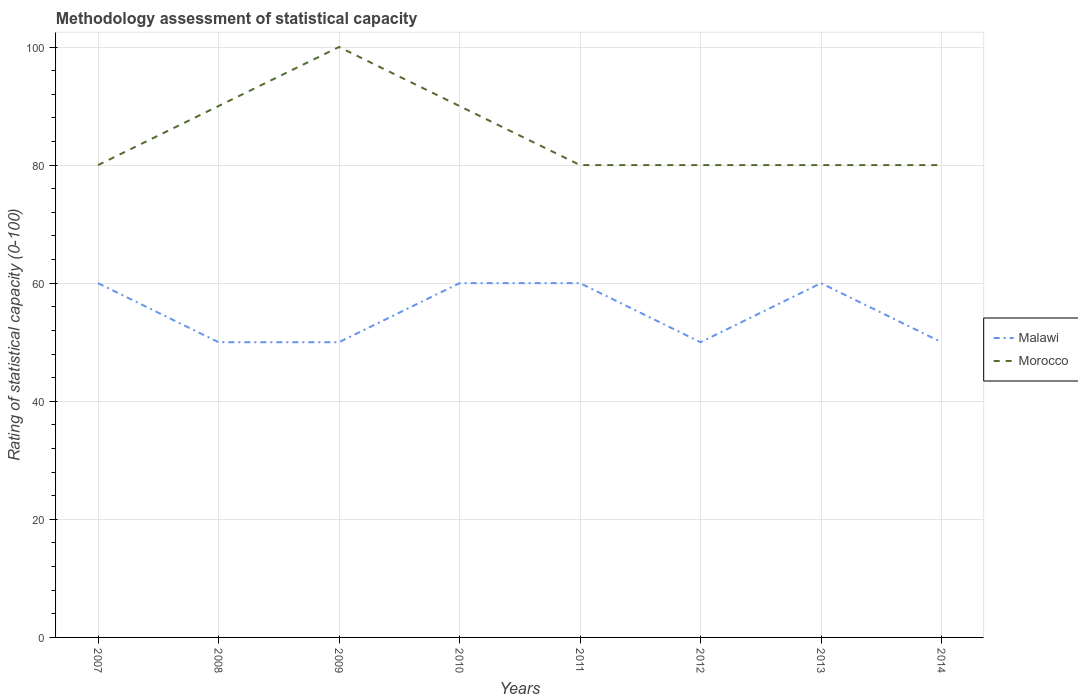How many different coloured lines are there?
Offer a terse response. 2. Is the number of lines equal to the number of legend labels?
Keep it short and to the point. Yes. Across all years, what is the maximum rating of statistical capacity in Morocco?
Offer a very short reply. 80. What is the total rating of statistical capacity in Morocco in the graph?
Offer a terse response. -10. What is the difference between the highest and the second highest rating of statistical capacity in Malawi?
Your answer should be compact. 10. Are the values on the major ticks of Y-axis written in scientific E-notation?
Your answer should be compact. No. Does the graph contain grids?
Your answer should be very brief. Yes. Where does the legend appear in the graph?
Make the answer very short. Center right. How are the legend labels stacked?
Offer a terse response. Vertical. What is the title of the graph?
Offer a very short reply. Methodology assessment of statistical capacity. What is the label or title of the X-axis?
Your answer should be very brief. Years. What is the label or title of the Y-axis?
Your answer should be very brief. Rating of statistical capacity (0-100). What is the Rating of statistical capacity (0-100) of Malawi in 2007?
Your response must be concise. 60. What is the Rating of statistical capacity (0-100) in Morocco in 2007?
Keep it short and to the point. 80. What is the Rating of statistical capacity (0-100) of Morocco in 2008?
Your answer should be very brief. 90. What is the Rating of statistical capacity (0-100) of Malawi in 2010?
Keep it short and to the point. 60. What is the Rating of statistical capacity (0-100) of Morocco in 2010?
Keep it short and to the point. 90. What is the Rating of statistical capacity (0-100) in Malawi in 2011?
Ensure brevity in your answer.  60. What is the Rating of statistical capacity (0-100) of Morocco in 2011?
Your response must be concise. 80. What is the Rating of statistical capacity (0-100) of Morocco in 2013?
Provide a short and direct response. 80. What is the Rating of statistical capacity (0-100) of Morocco in 2014?
Provide a succinct answer. 80. Across all years, what is the maximum Rating of statistical capacity (0-100) of Malawi?
Provide a succinct answer. 60. Across all years, what is the minimum Rating of statistical capacity (0-100) in Morocco?
Provide a succinct answer. 80. What is the total Rating of statistical capacity (0-100) in Malawi in the graph?
Your answer should be very brief. 440. What is the total Rating of statistical capacity (0-100) of Morocco in the graph?
Make the answer very short. 680. What is the difference between the Rating of statistical capacity (0-100) of Malawi in 2007 and that in 2008?
Give a very brief answer. 10. What is the difference between the Rating of statistical capacity (0-100) of Malawi in 2007 and that in 2011?
Make the answer very short. 0. What is the difference between the Rating of statistical capacity (0-100) in Morocco in 2007 and that in 2013?
Offer a terse response. 0. What is the difference between the Rating of statistical capacity (0-100) in Malawi in 2008 and that in 2010?
Keep it short and to the point. -10. What is the difference between the Rating of statistical capacity (0-100) in Morocco in 2008 and that in 2010?
Offer a very short reply. 0. What is the difference between the Rating of statistical capacity (0-100) of Malawi in 2008 and that in 2011?
Ensure brevity in your answer.  -10. What is the difference between the Rating of statistical capacity (0-100) of Morocco in 2008 and that in 2011?
Ensure brevity in your answer.  10. What is the difference between the Rating of statistical capacity (0-100) in Morocco in 2008 and that in 2012?
Your response must be concise. 10. What is the difference between the Rating of statistical capacity (0-100) in Malawi in 2008 and that in 2013?
Ensure brevity in your answer.  -10. What is the difference between the Rating of statistical capacity (0-100) in Malawi in 2009 and that in 2010?
Give a very brief answer. -10. What is the difference between the Rating of statistical capacity (0-100) in Morocco in 2009 and that in 2010?
Provide a short and direct response. 10. What is the difference between the Rating of statistical capacity (0-100) of Morocco in 2009 and that in 2012?
Give a very brief answer. 20. What is the difference between the Rating of statistical capacity (0-100) in Malawi in 2009 and that in 2013?
Give a very brief answer. -10. What is the difference between the Rating of statistical capacity (0-100) in Malawi in 2009 and that in 2014?
Your answer should be very brief. 0. What is the difference between the Rating of statistical capacity (0-100) in Morocco in 2009 and that in 2014?
Provide a short and direct response. 20. What is the difference between the Rating of statistical capacity (0-100) in Malawi in 2010 and that in 2011?
Give a very brief answer. 0. What is the difference between the Rating of statistical capacity (0-100) in Malawi in 2010 and that in 2012?
Your answer should be very brief. 10. What is the difference between the Rating of statistical capacity (0-100) in Morocco in 2010 and that in 2013?
Give a very brief answer. 10. What is the difference between the Rating of statistical capacity (0-100) in Malawi in 2011 and that in 2012?
Your answer should be very brief. 10. What is the difference between the Rating of statistical capacity (0-100) in Malawi in 2012 and that in 2013?
Ensure brevity in your answer.  -10. What is the difference between the Rating of statistical capacity (0-100) in Malawi in 2007 and the Rating of statistical capacity (0-100) in Morocco in 2010?
Provide a short and direct response. -30. What is the difference between the Rating of statistical capacity (0-100) in Malawi in 2007 and the Rating of statistical capacity (0-100) in Morocco in 2011?
Ensure brevity in your answer.  -20. What is the difference between the Rating of statistical capacity (0-100) of Malawi in 2007 and the Rating of statistical capacity (0-100) of Morocco in 2014?
Keep it short and to the point. -20. What is the difference between the Rating of statistical capacity (0-100) in Malawi in 2008 and the Rating of statistical capacity (0-100) in Morocco in 2009?
Provide a succinct answer. -50. What is the difference between the Rating of statistical capacity (0-100) of Malawi in 2008 and the Rating of statistical capacity (0-100) of Morocco in 2011?
Provide a short and direct response. -30. What is the difference between the Rating of statistical capacity (0-100) in Malawi in 2008 and the Rating of statistical capacity (0-100) in Morocco in 2012?
Your answer should be very brief. -30. What is the difference between the Rating of statistical capacity (0-100) in Malawi in 2008 and the Rating of statistical capacity (0-100) in Morocco in 2013?
Provide a short and direct response. -30. What is the difference between the Rating of statistical capacity (0-100) of Malawi in 2008 and the Rating of statistical capacity (0-100) of Morocco in 2014?
Your answer should be compact. -30. What is the difference between the Rating of statistical capacity (0-100) in Malawi in 2009 and the Rating of statistical capacity (0-100) in Morocco in 2011?
Your answer should be compact. -30. What is the difference between the Rating of statistical capacity (0-100) of Malawi in 2009 and the Rating of statistical capacity (0-100) of Morocco in 2012?
Your response must be concise. -30. What is the difference between the Rating of statistical capacity (0-100) in Malawi in 2009 and the Rating of statistical capacity (0-100) in Morocco in 2013?
Provide a short and direct response. -30. What is the difference between the Rating of statistical capacity (0-100) in Malawi in 2009 and the Rating of statistical capacity (0-100) in Morocco in 2014?
Offer a terse response. -30. What is the difference between the Rating of statistical capacity (0-100) of Malawi in 2010 and the Rating of statistical capacity (0-100) of Morocco in 2012?
Ensure brevity in your answer.  -20. What is the difference between the Rating of statistical capacity (0-100) in Malawi in 2010 and the Rating of statistical capacity (0-100) in Morocco in 2013?
Ensure brevity in your answer.  -20. What is the difference between the Rating of statistical capacity (0-100) of Malawi in 2010 and the Rating of statistical capacity (0-100) of Morocco in 2014?
Your answer should be compact. -20. What is the difference between the Rating of statistical capacity (0-100) in Malawi in 2012 and the Rating of statistical capacity (0-100) in Morocco in 2013?
Offer a very short reply. -30. What is the difference between the Rating of statistical capacity (0-100) of Malawi in 2013 and the Rating of statistical capacity (0-100) of Morocco in 2014?
Give a very brief answer. -20. What is the average Rating of statistical capacity (0-100) of Malawi per year?
Your response must be concise. 55. In the year 2007, what is the difference between the Rating of statistical capacity (0-100) in Malawi and Rating of statistical capacity (0-100) in Morocco?
Offer a very short reply. -20. In the year 2009, what is the difference between the Rating of statistical capacity (0-100) in Malawi and Rating of statistical capacity (0-100) in Morocco?
Provide a short and direct response. -50. In the year 2012, what is the difference between the Rating of statistical capacity (0-100) in Malawi and Rating of statistical capacity (0-100) in Morocco?
Provide a short and direct response. -30. In the year 2014, what is the difference between the Rating of statistical capacity (0-100) of Malawi and Rating of statistical capacity (0-100) of Morocco?
Your answer should be compact. -30. What is the ratio of the Rating of statistical capacity (0-100) of Malawi in 2007 to that in 2008?
Offer a terse response. 1.2. What is the ratio of the Rating of statistical capacity (0-100) of Malawi in 2007 to that in 2009?
Offer a very short reply. 1.2. What is the ratio of the Rating of statistical capacity (0-100) in Malawi in 2007 to that in 2011?
Provide a short and direct response. 1. What is the ratio of the Rating of statistical capacity (0-100) of Morocco in 2007 to that in 2011?
Your answer should be compact. 1. What is the ratio of the Rating of statistical capacity (0-100) of Morocco in 2007 to that in 2013?
Provide a succinct answer. 1. What is the ratio of the Rating of statistical capacity (0-100) of Morocco in 2007 to that in 2014?
Offer a very short reply. 1. What is the ratio of the Rating of statistical capacity (0-100) in Malawi in 2008 to that in 2009?
Provide a succinct answer. 1. What is the ratio of the Rating of statistical capacity (0-100) in Morocco in 2008 to that in 2009?
Your response must be concise. 0.9. What is the ratio of the Rating of statistical capacity (0-100) of Malawi in 2008 to that in 2010?
Give a very brief answer. 0.83. What is the ratio of the Rating of statistical capacity (0-100) of Malawi in 2008 to that in 2011?
Your response must be concise. 0.83. What is the ratio of the Rating of statistical capacity (0-100) of Malawi in 2008 to that in 2012?
Your answer should be compact. 1. What is the ratio of the Rating of statistical capacity (0-100) of Malawi in 2009 to that in 2010?
Make the answer very short. 0.83. What is the ratio of the Rating of statistical capacity (0-100) in Morocco in 2009 to that in 2010?
Your response must be concise. 1.11. What is the ratio of the Rating of statistical capacity (0-100) in Morocco in 2009 to that in 2011?
Your response must be concise. 1.25. What is the ratio of the Rating of statistical capacity (0-100) in Morocco in 2009 to that in 2012?
Offer a very short reply. 1.25. What is the ratio of the Rating of statistical capacity (0-100) in Morocco in 2009 to that in 2013?
Offer a terse response. 1.25. What is the ratio of the Rating of statistical capacity (0-100) in Morocco in 2009 to that in 2014?
Provide a succinct answer. 1.25. What is the ratio of the Rating of statistical capacity (0-100) in Morocco in 2010 to that in 2011?
Ensure brevity in your answer.  1.12. What is the ratio of the Rating of statistical capacity (0-100) in Morocco in 2010 to that in 2014?
Your answer should be very brief. 1.12. What is the ratio of the Rating of statistical capacity (0-100) in Morocco in 2011 to that in 2014?
Offer a very short reply. 1. What is the ratio of the Rating of statistical capacity (0-100) of Malawi in 2012 to that in 2013?
Your response must be concise. 0.83. What is the difference between the highest and the second highest Rating of statistical capacity (0-100) in Malawi?
Give a very brief answer. 0. What is the difference between the highest and the lowest Rating of statistical capacity (0-100) of Malawi?
Make the answer very short. 10. What is the difference between the highest and the lowest Rating of statistical capacity (0-100) in Morocco?
Provide a succinct answer. 20. 